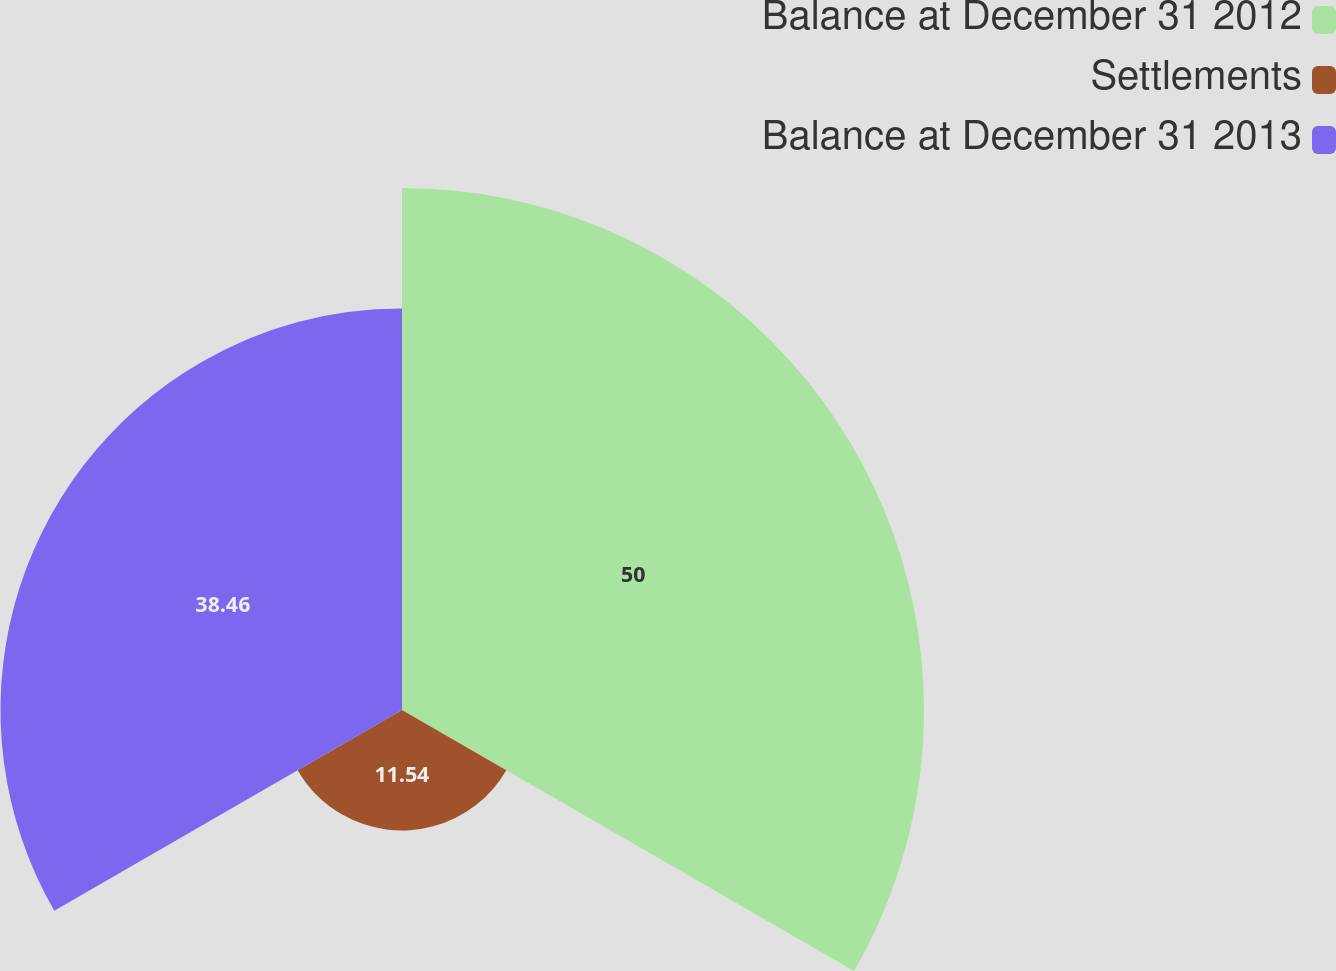<chart> <loc_0><loc_0><loc_500><loc_500><pie_chart><fcel>Balance at December 31 2012<fcel>Settlements<fcel>Balance at December 31 2013<nl><fcel>50.0%<fcel>11.54%<fcel>38.46%<nl></chart> 